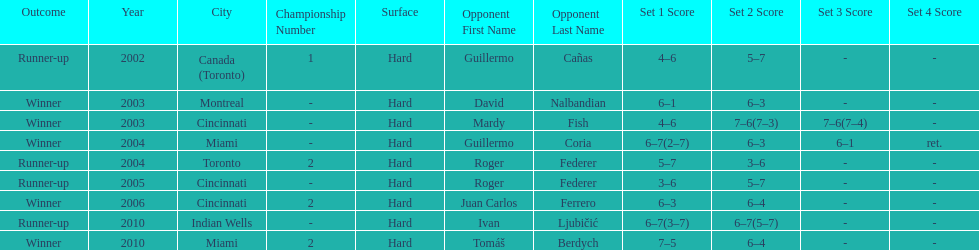How many times was the championship in miami? 2. 